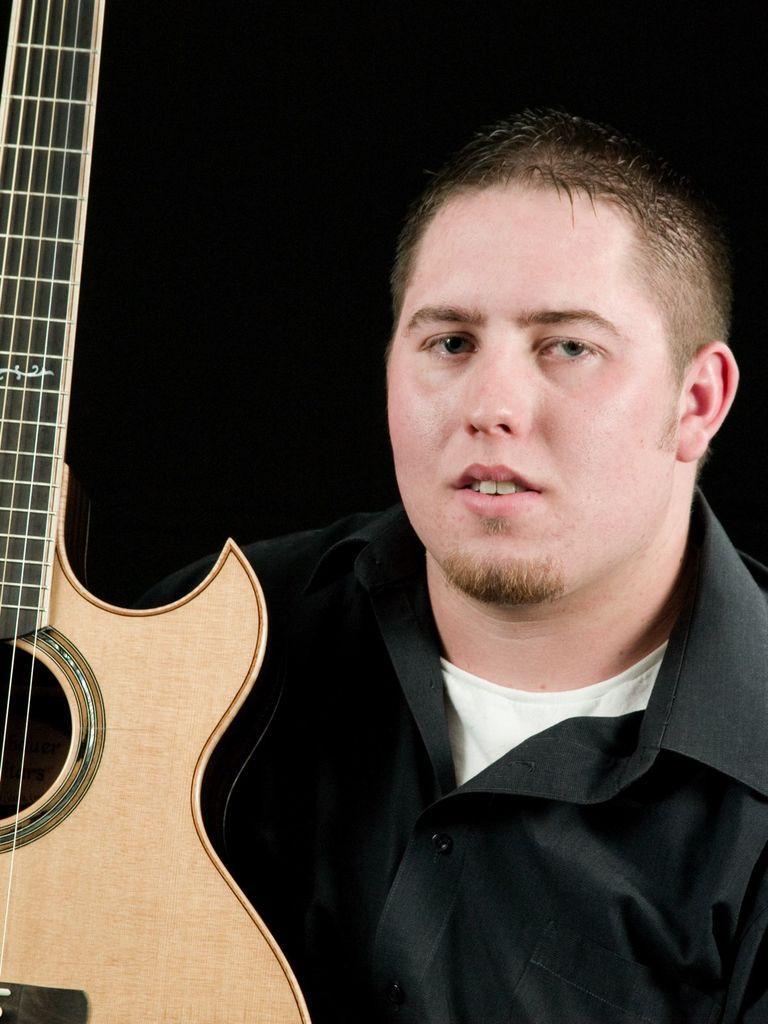Could you give a brief overview of what you see in this image? In this image I can see a person wearing black shirt. In front of him there is a guitar. 